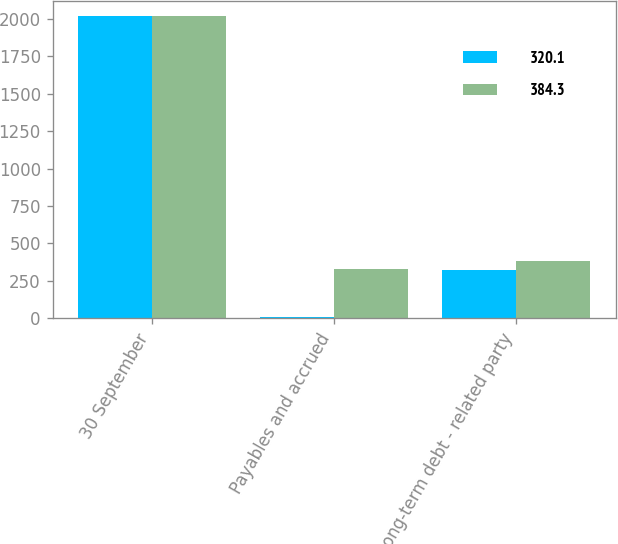Convert chart. <chart><loc_0><loc_0><loc_500><loc_500><stacked_bar_chart><ecel><fcel>30 September<fcel>Payables and accrued<fcel>Long-term debt - related party<nl><fcel>320.1<fcel>2019<fcel>8.9<fcel>320.1<nl><fcel>384.3<fcel>2018<fcel>330<fcel>384.3<nl></chart> 